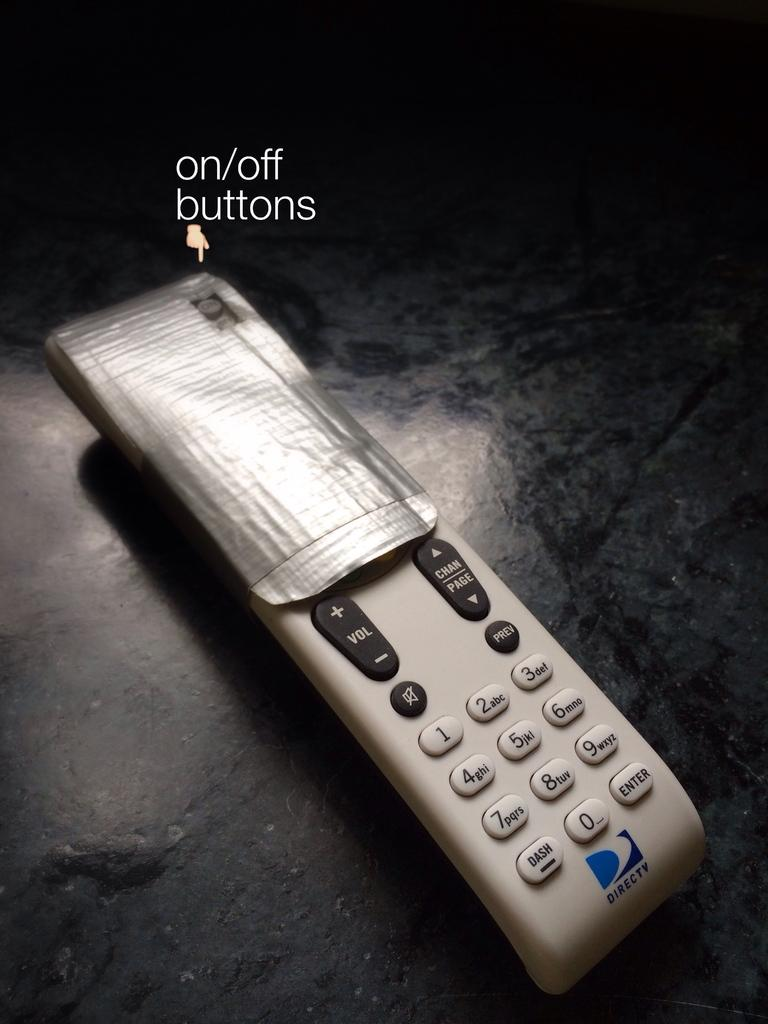<image>
Give a short and clear explanation of the subsequent image. Duck tape is covering all but the power button on the top half of a remote control and there is an emoji hand pointing down to it. 